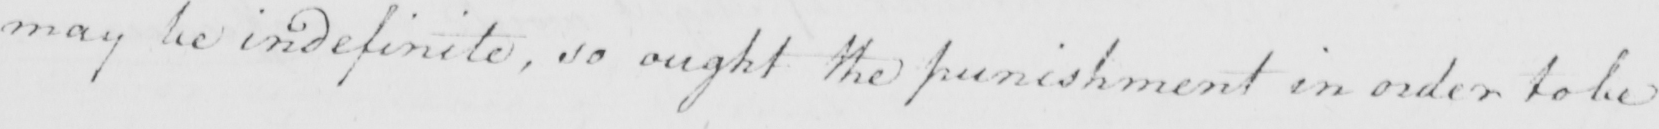Can you tell me what this handwritten text says? may be indefinite , so ought the punishment in order to be 